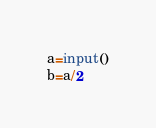<code> <loc_0><loc_0><loc_500><loc_500><_Python_>a=input()
b=a/2</code> 